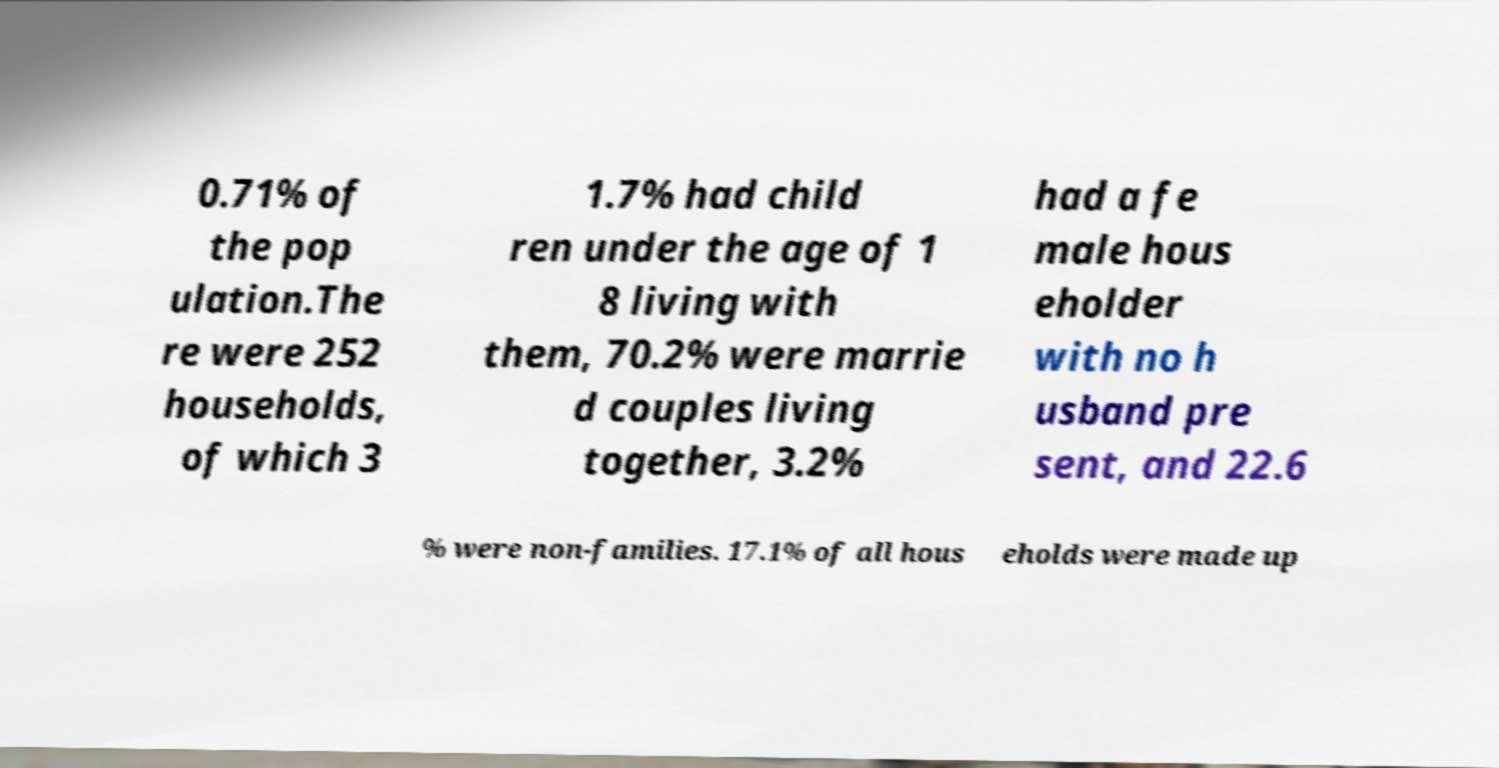Could you extract and type out the text from this image? 0.71% of the pop ulation.The re were 252 households, of which 3 1.7% had child ren under the age of 1 8 living with them, 70.2% were marrie d couples living together, 3.2% had a fe male hous eholder with no h usband pre sent, and 22.6 % were non-families. 17.1% of all hous eholds were made up 